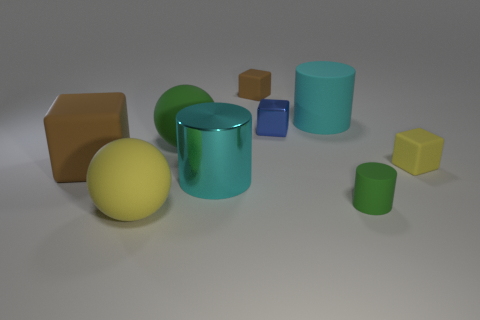Add 1 small gray matte cubes. How many objects exist? 10 Subtract all cylinders. How many objects are left? 6 Add 1 tiny gray rubber balls. How many tiny gray rubber balls exist? 1 Subtract 0 green blocks. How many objects are left? 9 Subtract all tiny yellow blocks. Subtract all cyan shiny cylinders. How many objects are left? 7 Add 2 big cyan cylinders. How many big cyan cylinders are left? 4 